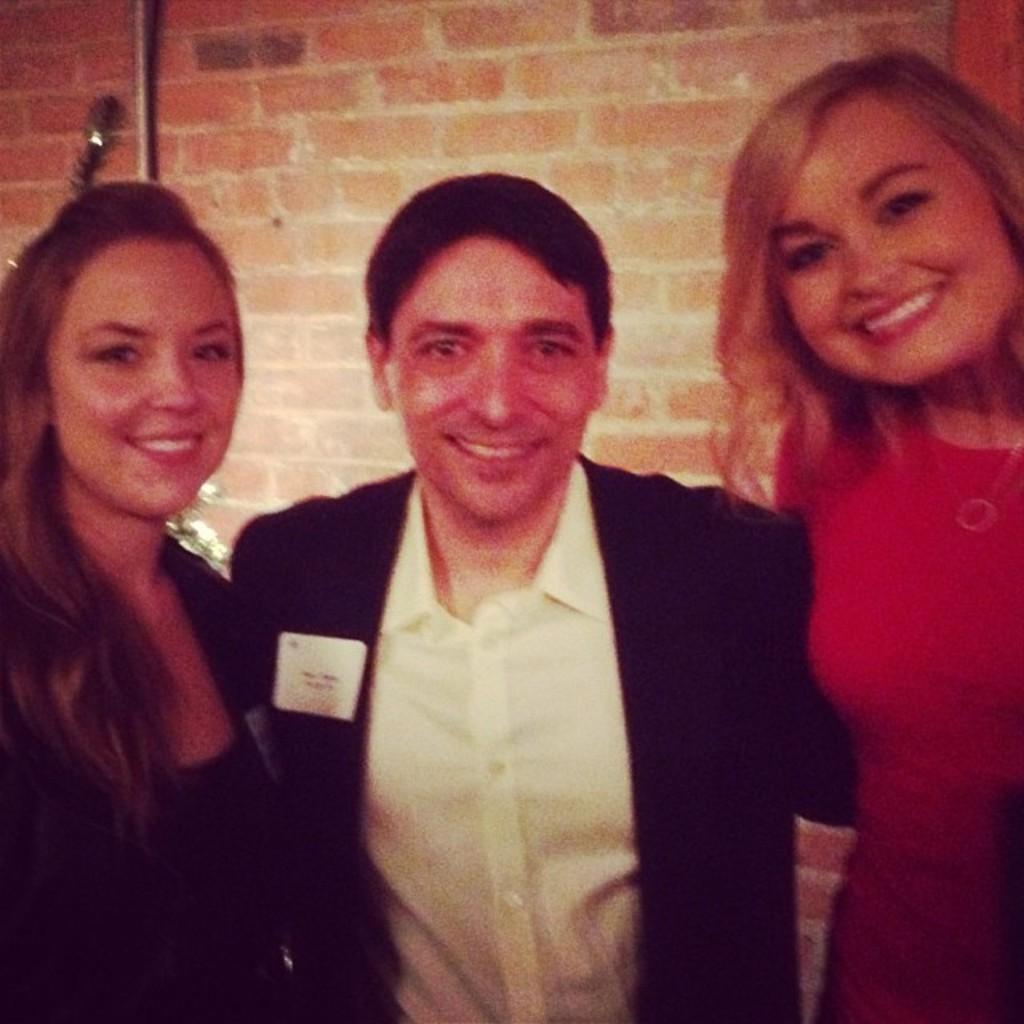Can you describe this image briefly? This is the picture of two ladies and a guy who is wearing the suit and behind there is a brick wall. 